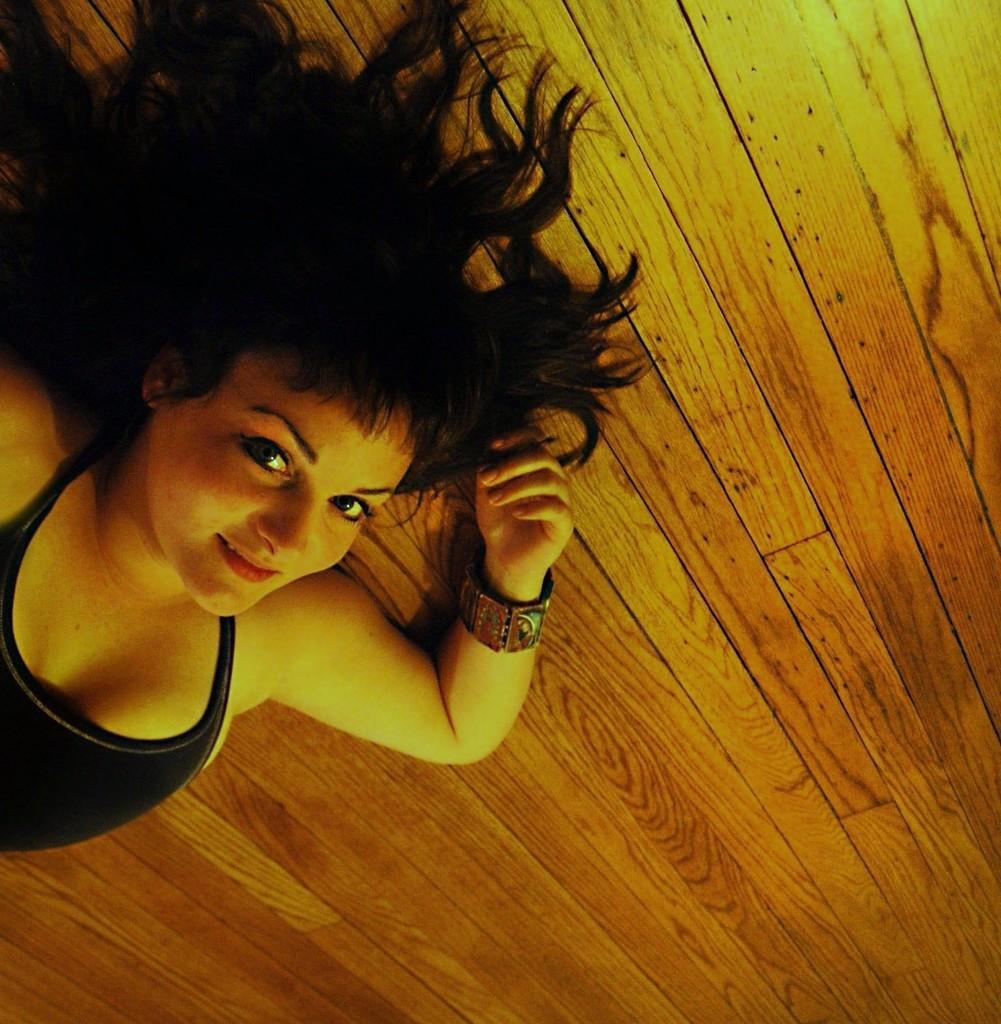In one or two sentences, can you explain what this image depicts? In this image I can see a woman wearing black color dress is laying on the wooden surface which his brown in color. 